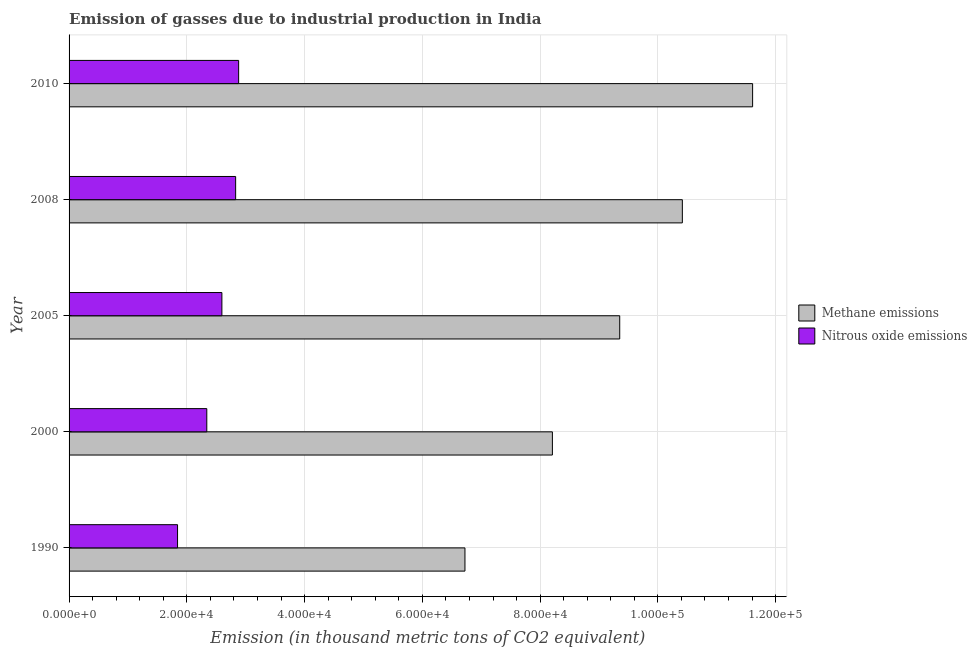How many different coloured bars are there?
Offer a terse response. 2. How many groups of bars are there?
Give a very brief answer. 5. Are the number of bars on each tick of the Y-axis equal?
Your answer should be very brief. Yes. How many bars are there on the 1st tick from the top?
Offer a terse response. 2. In how many cases, is the number of bars for a given year not equal to the number of legend labels?
Make the answer very short. 0. What is the amount of methane emissions in 2010?
Ensure brevity in your answer.  1.16e+05. Across all years, what is the maximum amount of nitrous oxide emissions?
Ensure brevity in your answer.  2.88e+04. Across all years, what is the minimum amount of nitrous oxide emissions?
Your response must be concise. 1.84e+04. In which year was the amount of methane emissions maximum?
Keep it short and to the point. 2010. In which year was the amount of methane emissions minimum?
Provide a short and direct response. 1990. What is the total amount of methane emissions in the graph?
Provide a succinct answer. 4.63e+05. What is the difference between the amount of methane emissions in 2005 and that in 2008?
Offer a very short reply. -1.06e+04. What is the difference between the amount of nitrous oxide emissions in 2000 and the amount of methane emissions in 2008?
Offer a terse response. -8.08e+04. What is the average amount of methane emissions per year?
Your answer should be compact. 9.26e+04. In the year 2005, what is the difference between the amount of nitrous oxide emissions and amount of methane emissions?
Provide a succinct answer. -6.76e+04. In how many years, is the amount of nitrous oxide emissions greater than 52000 thousand metric tons?
Give a very brief answer. 0. What is the ratio of the amount of nitrous oxide emissions in 1990 to that in 2008?
Provide a short and direct response. 0.65. Is the amount of nitrous oxide emissions in 2008 less than that in 2010?
Offer a very short reply. Yes. Is the difference between the amount of methane emissions in 1990 and 2005 greater than the difference between the amount of nitrous oxide emissions in 1990 and 2005?
Your answer should be compact. No. What is the difference between the highest and the second highest amount of nitrous oxide emissions?
Your answer should be compact. 510. What is the difference between the highest and the lowest amount of methane emissions?
Your answer should be compact. 4.89e+04. In how many years, is the amount of nitrous oxide emissions greater than the average amount of nitrous oxide emissions taken over all years?
Keep it short and to the point. 3. Is the sum of the amount of nitrous oxide emissions in 2005 and 2008 greater than the maximum amount of methane emissions across all years?
Your response must be concise. No. What does the 1st bar from the top in 1990 represents?
Your answer should be very brief. Nitrous oxide emissions. What does the 1st bar from the bottom in 2005 represents?
Your answer should be very brief. Methane emissions. Are the values on the major ticks of X-axis written in scientific E-notation?
Ensure brevity in your answer.  Yes. Does the graph contain grids?
Provide a short and direct response. Yes. How many legend labels are there?
Your answer should be compact. 2. How are the legend labels stacked?
Provide a short and direct response. Vertical. What is the title of the graph?
Your answer should be compact. Emission of gasses due to industrial production in India. Does "Chemicals" appear as one of the legend labels in the graph?
Offer a very short reply. No. What is the label or title of the X-axis?
Make the answer very short. Emission (in thousand metric tons of CO2 equivalent). What is the Emission (in thousand metric tons of CO2 equivalent) in Methane emissions in 1990?
Give a very brief answer. 6.72e+04. What is the Emission (in thousand metric tons of CO2 equivalent) in Nitrous oxide emissions in 1990?
Your answer should be compact. 1.84e+04. What is the Emission (in thousand metric tons of CO2 equivalent) in Methane emissions in 2000?
Provide a succinct answer. 8.21e+04. What is the Emission (in thousand metric tons of CO2 equivalent) in Nitrous oxide emissions in 2000?
Your answer should be very brief. 2.34e+04. What is the Emission (in thousand metric tons of CO2 equivalent) in Methane emissions in 2005?
Make the answer very short. 9.35e+04. What is the Emission (in thousand metric tons of CO2 equivalent) in Nitrous oxide emissions in 2005?
Give a very brief answer. 2.60e+04. What is the Emission (in thousand metric tons of CO2 equivalent) of Methane emissions in 2008?
Your answer should be very brief. 1.04e+05. What is the Emission (in thousand metric tons of CO2 equivalent) in Nitrous oxide emissions in 2008?
Your answer should be compact. 2.83e+04. What is the Emission (in thousand metric tons of CO2 equivalent) of Methane emissions in 2010?
Offer a very short reply. 1.16e+05. What is the Emission (in thousand metric tons of CO2 equivalent) of Nitrous oxide emissions in 2010?
Keep it short and to the point. 2.88e+04. Across all years, what is the maximum Emission (in thousand metric tons of CO2 equivalent) of Methane emissions?
Keep it short and to the point. 1.16e+05. Across all years, what is the maximum Emission (in thousand metric tons of CO2 equivalent) of Nitrous oxide emissions?
Provide a succinct answer. 2.88e+04. Across all years, what is the minimum Emission (in thousand metric tons of CO2 equivalent) in Methane emissions?
Provide a short and direct response. 6.72e+04. Across all years, what is the minimum Emission (in thousand metric tons of CO2 equivalent) of Nitrous oxide emissions?
Ensure brevity in your answer.  1.84e+04. What is the total Emission (in thousand metric tons of CO2 equivalent) in Methane emissions in the graph?
Offer a terse response. 4.63e+05. What is the total Emission (in thousand metric tons of CO2 equivalent) in Nitrous oxide emissions in the graph?
Keep it short and to the point. 1.25e+05. What is the difference between the Emission (in thousand metric tons of CO2 equivalent) of Methane emissions in 1990 and that in 2000?
Provide a succinct answer. -1.49e+04. What is the difference between the Emission (in thousand metric tons of CO2 equivalent) of Nitrous oxide emissions in 1990 and that in 2000?
Offer a very short reply. -4968.5. What is the difference between the Emission (in thousand metric tons of CO2 equivalent) in Methane emissions in 1990 and that in 2005?
Your response must be concise. -2.63e+04. What is the difference between the Emission (in thousand metric tons of CO2 equivalent) in Nitrous oxide emissions in 1990 and that in 2005?
Keep it short and to the point. -7531.6. What is the difference between the Emission (in thousand metric tons of CO2 equivalent) in Methane emissions in 1990 and that in 2008?
Offer a terse response. -3.69e+04. What is the difference between the Emission (in thousand metric tons of CO2 equivalent) in Nitrous oxide emissions in 1990 and that in 2008?
Your response must be concise. -9867.5. What is the difference between the Emission (in thousand metric tons of CO2 equivalent) of Methane emissions in 1990 and that in 2010?
Provide a succinct answer. -4.89e+04. What is the difference between the Emission (in thousand metric tons of CO2 equivalent) of Nitrous oxide emissions in 1990 and that in 2010?
Ensure brevity in your answer.  -1.04e+04. What is the difference between the Emission (in thousand metric tons of CO2 equivalent) of Methane emissions in 2000 and that in 2005?
Offer a terse response. -1.14e+04. What is the difference between the Emission (in thousand metric tons of CO2 equivalent) in Nitrous oxide emissions in 2000 and that in 2005?
Provide a short and direct response. -2563.1. What is the difference between the Emission (in thousand metric tons of CO2 equivalent) in Methane emissions in 2000 and that in 2008?
Keep it short and to the point. -2.21e+04. What is the difference between the Emission (in thousand metric tons of CO2 equivalent) of Nitrous oxide emissions in 2000 and that in 2008?
Ensure brevity in your answer.  -4899. What is the difference between the Emission (in thousand metric tons of CO2 equivalent) in Methane emissions in 2000 and that in 2010?
Make the answer very short. -3.40e+04. What is the difference between the Emission (in thousand metric tons of CO2 equivalent) of Nitrous oxide emissions in 2000 and that in 2010?
Make the answer very short. -5409. What is the difference between the Emission (in thousand metric tons of CO2 equivalent) of Methane emissions in 2005 and that in 2008?
Give a very brief answer. -1.06e+04. What is the difference between the Emission (in thousand metric tons of CO2 equivalent) in Nitrous oxide emissions in 2005 and that in 2008?
Offer a very short reply. -2335.9. What is the difference between the Emission (in thousand metric tons of CO2 equivalent) in Methane emissions in 2005 and that in 2010?
Offer a very short reply. -2.26e+04. What is the difference between the Emission (in thousand metric tons of CO2 equivalent) of Nitrous oxide emissions in 2005 and that in 2010?
Provide a succinct answer. -2845.9. What is the difference between the Emission (in thousand metric tons of CO2 equivalent) in Methane emissions in 2008 and that in 2010?
Provide a succinct answer. -1.19e+04. What is the difference between the Emission (in thousand metric tons of CO2 equivalent) of Nitrous oxide emissions in 2008 and that in 2010?
Your response must be concise. -510. What is the difference between the Emission (in thousand metric tons of CO2 equivalent) of Methane emissions in 1990 and the Emission (in thousand metric tons of CO2 equivalent) of Nitrous oxide emissions in 2000?
Provide a short and direct response. 4.38e+04. What is the difference between the Emission (in thousand metric tons of CO2 equivalent) in Methane emissions in 1990 and the Emission (in thousand metric tons of CO2 equivalent) in Nitrous oxide emissions in 2005?
Provide a short and direct response. 4.13e+04. What is the difference between the Emission (in thousand metric tons of CO2 equivalent) in Methane emissions in 1990 and the Emission (in thousand metric tons of CO2 equivalent) in Nitrous oxide emissions in 2008?
Offer a terse response. 3.89e+04. What is the difference between the Emission (in thousand metric tons of CO2 equivalent) of Methane emissions in 1990 and the Emission (in thousand metric tons of CO2 equivalent) of Nitrous oxide emissions in 2010?
Your response must be concise. 3.84e+04. What is the difference between the Emission (in thousand metric tons of CO2 equivalent) of Methane emissions in 2000 and the Emission (in thousand metric tons of CO2 equivalent) of Nitrous oxide emissions in 2005?
Give a very brief answer. 5.61e+04. What is the difference between the Emission (in thousand metric tons of CO2 equivalent) of Methane emissions in 2000 and the Emission (in thousand metric tons of CO2 equivalent) of Nitrous oxide emissions in 2008?
Keep it short and to the point. 5.38e+04. What is the difference between the Emission (in thousand metric tons of CO2 equivalent) of Methane emissions in 2000 and the Emission (in thousand metric tons of CO2 equivalent) of Nitrous oxide emissions in 2010?
Your answer should be very brief. 5.33e+04. What is the difference between the Emission (in thousand metric tons of CO2 equivalent) in Methane emissions in 2005 and the Emission (in thousand metric tons of CO2 equivalent) in Nitrous oxide emissions in 2008?
Offer a terse response. 6.52e+04. What is the difference between the Emission (in thousand metric tons of CO2 equivalent) in Methane emissions in 2005 and the Emission (in thousand metric tons of CO2 equivalent) in Nitrous oxide emissions in 2010?
Offer a terse response. 6.47e+04. What is the difference between the Emission (in thousand metric tons of CO2 equivalent) of Methane emissions in 2008 and the Emission (in thousand metric tons of CO2 equivalent) of Nitrous oxide emissions in 2010?
Provide a succinct answer. 7.54e+04. What is the average Emission (in thousand metric tons of CO2 equivalent) in Methane emissions per year?
Offer a terse response. 9.26e+04. What is the average Emission (in thousand metric tons of CO2 equivalent) in Nitrous oxide emissions per year?
Your answer should be compact. 2.50e+04. In the year 1990, what is the difference between the Emission (in thousand metric tons of CO2 equivalent) of Methane emissions and Emission (in thousand metric tons of CO2 equivalent) of Nitrous oxide emissions?
Your response must be concise. 4.88e+04. In the year 2000, what is the difference between the Emission (in thousand metric tons of CO2 equivalent) in Methane emissions and Emission (in thousand metric tons of CO2 equivalent) in Nitrous oxide emissions?
Your answer should be very brief. 5.87e+04. In the year 2005, what is the difference between the Emission (in thousand metric tons of CO2 equivalent) in Methane emissions and Emission (in thousand metric tons of CO2 equivalent) in Nitrous oxide emissions?
Ensure brevity in your answer.  6.76e+04. In the year 2008, what is the difference between the Emission (in thousand metric tons of CO2 equivalent) of Methane emissions and Emission (in thousand metric tons of CO2 equivalent) of Nitrous oxide emissions?
Provide a succinct answer. 7.59e+04. In the year 2010, what is the difference between the Emission (in thousand metric tons of CO2 equivalent) of Methane emissions and Emission (in thousand metric tons of CO2 equivalent) of Nitrous oxide emissions?
Offer a terse response. 8.73e+04. What is the ratio of the Emission (in thousand metric tons of CO2 equivalent) of Methane emissions in 1990 to that in 2000?
Provide a succinct answer. 0.82. What is the ratio of the Emission (in thousand metric tons of CO2 equivalent) in Nitrous oxide emissions in 1990 to that in 2000?
Offer a very short reply. 0.79. What is the ratio of the Emission (in thousand metric tons of CO2 equivalent) in Methane emissions in 1990 to that in 2005?
Provide a short and direct response. 0.72. What is the ratio of the Emission (in thousand metric tons of CO2 equivalent) of Nitrous oxide emissions in 1990 to that in 2005?
Ensure brevity in your answer.  0.71. What is the ratio of the Emission (in thousand metric tons of CO2 equivalent) of Methane emissions in 1990 to that in 2008?
Your answer should be compact. 0.65. What is the ratio of the Emission (in thousand metric tons of CO2 equivalent) of Nitrous oxide emissions in 1990 to that in 2008?
Provide a short and direct response. 0.65. What is the ratio of the Emission (in thousand metric tons of CO2 equivalent) of Methane emissions in 1990 to that in 2010?
Ensure brevity in your answer.  0.58. What is the ratio of the Emission (in thousand metric tons of CO2 equivalent) in Nitrous oxide emissions in 1990 to that in 2010?
Keep it short and to the point. 0.64. What is the ratio of the Emission (in thousand metric tons of CO2 equivalent) in Methane emissions in 2000 to that in 2005?
Make the answer very short. 0.88. What is the ratio of the Emission (in thousand metric tons of CO2 equivalent) in Nitrous oxide emissions in 2000 to that in 2005?
Offer a terse response. 0.9. What is the ratio of the Emission (in thousand metric tons of CO2 equivalent) in Methane emissions in 2000 to that in 2008?
Offer a terse response. 0.79. What is the ratio of the Emission (in thousand metric tons of CO2 equivalent) in Nitrous oxide emissions in 2000 to that in 2008?
Your response must be concise. 0.83. What is the ratio of the Emission (in thousand metric tons of CO2 equivalent) of Methane emissions in 2000 to that in 2010?
Give a very brief answer. 0.71. What is the ratio of the Emission (in thousand metric tons of CO2 equivalent) of Nitrous oxide emissions in 2000 to that in 2010?
Provide a succinct answer. 0.81. What is the ratio of the Emission (in thousand metric tons of CO2 equivalent) in Methane emissions in 2005 to that in 2008?
Make the answer very short. 0.9. What is the ratio of the Emission (in thousand metric tons of CO2 equivalent) of Nitrous oxide emissions in 2005 to that in 2008?
Give a very brief answer. 0.92. What is the ratio of the Emission (in thousand metric tons of CO2 equivalent) of Methane emissions in 2005 to that in 2010?
Ensure brevity in your answer.  0.81. What is the ratio of the Emission (in thousand metric tons of CO2 equivalent) of Nitrous oxide emissions in 2005 to that in 2010?
Your response must be concise. 0.9. What is the ratio of the Emission (in thousand metric tons of CO2 equivalent) of Methane emissions in 2008 to that in 2010?
Your response must be concise. 0.9. What is the ratio of the Emission (in thousand metric tons of CO2 equivalent) of Nitrous oxide emissions in 2008 to that in 2010?
Provide a succinct answer. 0.98. What is the difference between the highest and the second highest Emission (in thousand metric tons of CO2 equivalent) in Methane emissions?
Provide a succinct answer. 1.19e+04. What is the difference between the highest and the second highest Emission (in thousand metric tons of CO2 equivalent) of Nitrous oxide emissions?
Your response must be concise. 510. What is the difference between the highest and the lowest Emission (in thousand metric tons of CO2 equivalent) in Methane emissions?
Your answer should be compact. 4.89e+04. What is the difference between the highest and the lowest Emission (in thousand metric tons of CO2 equivalent) of Nitrous oxide emissions?
Your answer should be compact. 1.04e+04. 